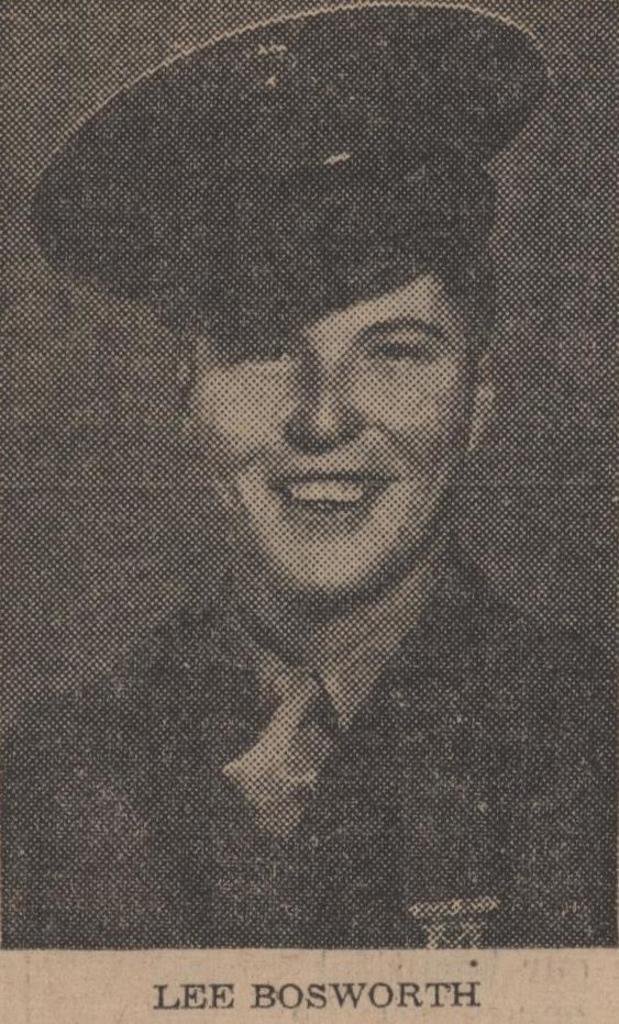In one or two sentences, can you explain what this image depicts? In this image we can see the paper and on the paper we can see the person wearing the cap and smiling. We can also see the name at the bottom. 